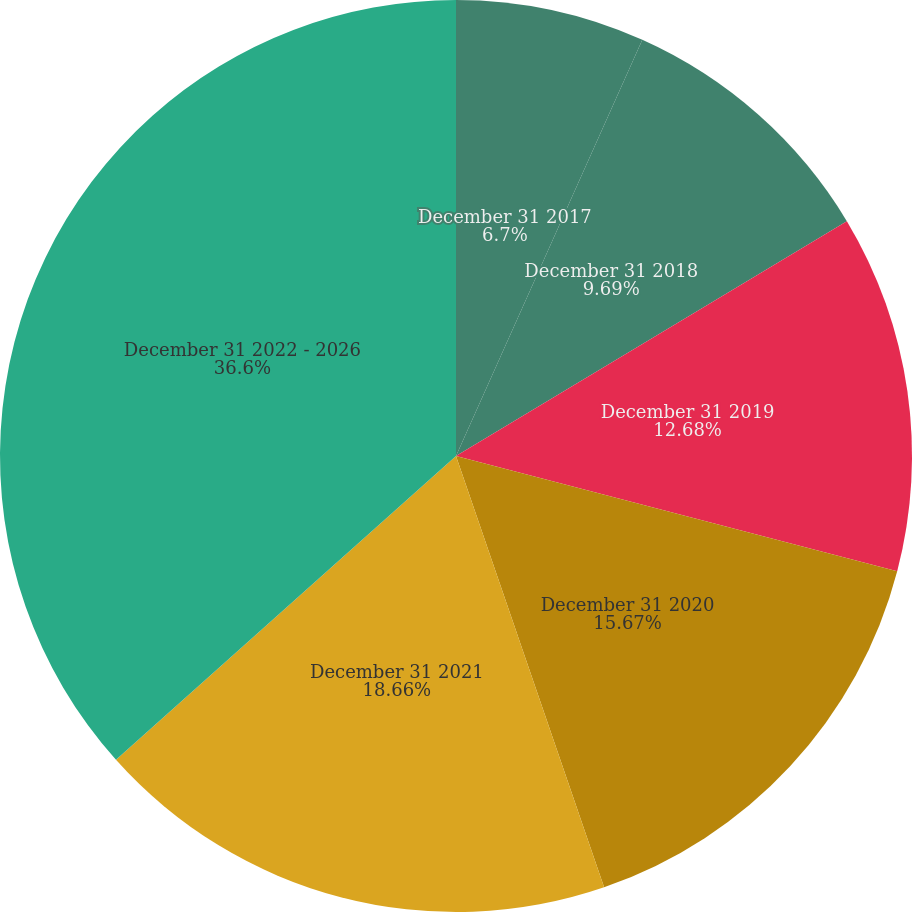<chart> <loc_0><loc_0><loc_500><loc_500><pie_chart><fcel>December 31 2017<fcel>December 31 2018<fcel>December 31 2019<fcel>December 31 2020<fcel>December 31 2021<fcel>December 31 2022 - 2026<nl><fcel>6.7%<fcel>9.69%<fcel>12.68%<fcel>15.67%<fcel>18.66%<fcel>36.61%<nl></chart> 